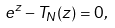Convert formula to latex. <formula><loc_0><loc_0><loc_500><loc_500>e ^ { z } - T _ { N } ( z ) = 0 ,</formula> 